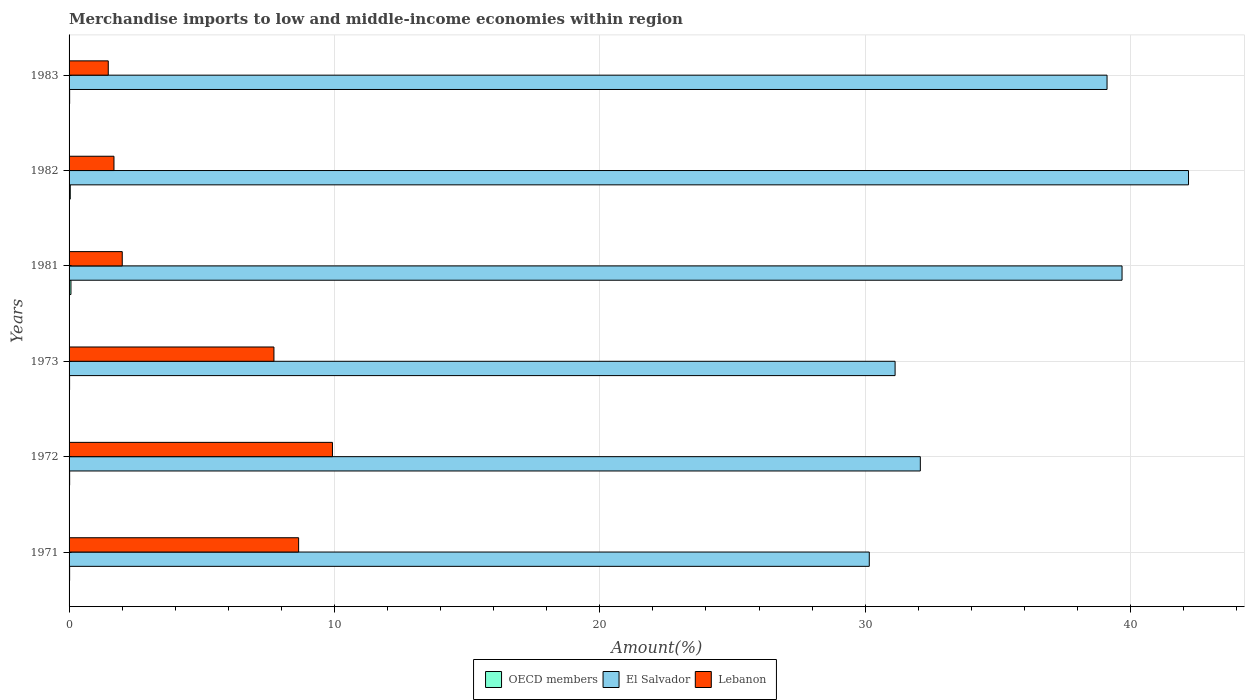Are the number of bars per tick equal to the number of legend labels?
Give a very brief answer. Yes. What is the label of the 1st group of bars from the top?
Your answer should be compact. 1983. What is the percentage of amount earned from merchandise imports in El Salvador in 1972?
Your answer should be compact. 32.08. Across all years, what is the maximum percentage of amount earned from merchandise imports in El Salvador?
Offer a terse response. 42.19. Across all years, what is the minimum percentage of amount earned from merchandise imports in El Salvador?
Offer a very short reply. 30.16. In which year was the percentage of amount earned from merchandise imports in El Salvador minimum?
Offer a terse response. 1971. What is the total percentage of amount earned from merchandise imports in Lebanon in the graph?
Your answer should be very brief. 31.47. What is the difference between the percentage of amount earned from merchandise imports in El Salvador in 1971 and that in 1981?
Provide a short and direct response. -9.53. What is the difference between the percentage of amount earned from merchandise imports in Lebanon in 1981 and the percentage of amount earned from merchandise imports in OECD members in 1972?
Offer a very short reply. 1.98. What is the average percentage of amount earned from merchandise imports in El Salvador per year?
Ensure brevity in your answer.  35.72. In the year 1983, what is the difference between the percentage of amount earned from merchandise imports in Lebanon and percentage of amount earned from merchandise imports in OECD members?
Make the answer very short. 1.46. In how many years, is the percentage of amount earned from merchandise imports in Lebanon greater than 16 %?
Offer a very short reply. 0. What is the ratio of the percentage of amount earned from merchandise imports in OECD members in 1973 to that in 1981?
Provide a short and direct response. 0.28. Is the percentage of amount earned from merchandise imports in Lebanon in 1971 less than that in 1981?
Provide a short and direct response. No. Is the difference between the percentage of amount earned from merchandise imports in Lebanon in 1981 and 1982 greater than the difference between the percentage of amount earned from merchandise imports in OECD members in 1981 and 1982?
Your response must be concise. Yes. What is the difference between the highest and the second highest percentage of amount earned from merchandise imports in Lebanon?
Give a very brief answer. 1.28. What is the difference between the highest and the lowest percentage of amount earned from merchandise imports in El Salvador?
Your answer should be compact. 12.03. In how many years, is the percentage of amount earned from merchandise imports in Lebanon greater than the average percentage of amount earned from merchandise imports in Lebanon taken over all years?
Make the answer very short. 3. What does the 2nd bar from the top in 1982 represents?
Offer a terse response. El Salvador. What does the 3rd bar from the bottom in 1973 represents?
Your response must be concise. Lebanon. Is it the case that in every year, the sum of the percentage of amount earned from merchandise imports in Lebanon and percentage of amount earned from merchandise imports in El Salvador is greater than the percentage of amount earned from merchandise imports in OECD members?
Your answer should be very brief. Yes. How many bars are there?
Keep it short and to the point. 18. What is the difference between two consecutive major ticks on the X-axis?
Offer a very short reply. 10. Are the values on the major ticks of X-axis written in scientific E-notation?
Give a very brief answer. No. Does the graph contain any zero values?
Offer a terse response. No. How many legend labels are there?
Ensure brevity in your answer.  3. What is the title of the graph?
Your answer should be very brief. Merchandise imports to low and middle-income economies within region. What is the label or title of the X-axis?
Provide a short and direct response. Amount(%). What is the label or title of the Y-axis?
Give a very brief answer. Years. What is the Amount(%) of OECD members in 1971?
Keep it short and to the point. 0.02. What is the Amount(%) in El Salvador in 1971?
Provide a succinct answer. 30.16. What is the Amount(%) in Lebanon in 1971?
Give a very brief answer. 8.65. What is the Amount(%) in OECD members in 1972?
Your response must be concise. 0.02. What is the Amount(%) of El Salvador in 1972?
Provide a succinct answer. 32.08. What is the Amount(%) of Lebanon in 1972?
Provide a succinct answer. 9.93. What is the Amount(%) in OECD members in 1973?
Offer a very short reply. 0.02. What is the Amount(%) of El Salvador in 1973?
Keep it short and to the point. 31.13. What is the Amount(%) in Lebanon in 1973?
Give a very brief answer. 7.72. What is the Amount(%) of OECD members in 1981?
Ensure brevity in your answer.  0.07. What is the Amount(%) in El Salvador in 1981?
Offer a very short reply. 39.68. What is the Amount(%) of Lebanon in 1981?
Ensure brevity in your answer.  2. What is the Amount(%) of OECD members in 1982?
Your response must be concise. 0.05. What is the Amount(%) in El Salvador in 1982?
Provide a short and direct response. 42.19. What is the Amount(%) in Lebanon in 1982?
Your answer should be compact. 1.69. What is the Amount(%) of OECD members in 1983?
Provide a succinct answer. 0.02. What is the Amount(%) of El Salvador in 1983?
Your answer should be very brief. 39.12. What is the Amount(%) in Lebanon in 1983?
Give a very brief answer. 1.48. Across all years, what is the maximum Amount(%) in OECD members?
Your answer should be very brief. 0.07. Across all years, what is the maximum Amount(%) of El Salvador?
Keep it short and to the point. 42.19. Across all years, what is the maximum Amount(%) in Lebanon?
Make the answer very short. 9.93. Across all years, what is the minimum Amount(%) of OECD members?
Make the answer very short. 0.02. Across all years, what is the minimum Amount(%) of El Salvador?
Offer a very short reply. 30.16. Across all years, what is the minimum Amount(%) of Lebanon?
Give a very brief answer. 1.48. What is the total Amount(%) in OECD members in the graph?
Provide a succinct answer. 0.2. What is the total Amount(%) in El Salvador in the graph?
Your answer should be very brief. 214.34. What is the total Amount(%) of Lebanon in the graph?
Keep it short and to the point. 31.47. What is the difference between the Amount(%) of OECD members in 1971 and that in 1972?
Offer a very short reply. -0. What is the difference between the Amount(%) in El Salvador in 1971 and that in 1972?
Your response must be concise. -1.92. What is the difference between the Amount(%) of Lebanon in 1971 and that in 1972?
Make the answer very short. -1.28. What is the difference between the Amount(%) in OECD members in 1971 and that in 1973?
Your answer should be compact. 0. What is the difference between the Amount(%) in El Salvador in 1971 and that in 1973?
Provide a short and direct response. -0.97. What is the difference between the Amount(%) in OECD members in 1971 and that in 1981?
Offer a terse response. -0.05. What is the difference between the Amount(%) of El Salvador in 1971 and that in 1981?
Your response must be concise. -9.53. What is the difference between the Amount(%) in Lebanon in 1971 and that in 1981?
Give a very brief answer. 6.65. What is the difference between the Amount(%) of OECD members in 1971 and that in 1982?
Ensure brevity in your answer.  -0.02. What is the difference between the Amount(%) in El Salvador in 1971 and that in 1982?
Ensure brevity in your answer.  -12.03. What is the difference between the Amount(%) of Lebanon in 1971 and that in 1982?
Make the answer very short. 6.96. What is the difference between the Amount(%) of OECD members in 1971 and that in 1983?
Provide a short and direct response. -0. What is the difference between the Amount(%) of El Salvador in 1971 and that in 1983?
Make the answer very short. -8.96. What is the difference between the Amount(%) in Lebanon in 1971 and that in 1983?
Offer a very short reply. 7.17. What is the difference between the Amount(%) of OECD members in 1972 and that in 1973?
Offer a very short reply. 0. What is the difference between the Amount(%) of El Salvador in 1972 and that in 1973?
Offer a terse response. 0.95. What is the difference between the Amount(%) in Lebanon in 1972 and that in 1973?
Give a very brief answer. 2.21. What is the difference between the Amount(%) of OECD members in 1972 and that in 1981?
Your response must be concise. -0.05. What is the difference between the Amount(%) of El Salvador in 1972 and that in 1981?
Provide a succinct answer. -7.6. What is the difference between the Amount(%) in Lebanon in 1972 and that in 1981?
Provide a succinct answer. 7.92. What is the difference between the Amount(%) of OECD members in 1972 and that in 1982?
Provide a short and direct response. -0.02. What is the difference between the Amount(%) of El Salvador in 1972 and that in 1982?
Offer a very short reply. -10.11. What is the difference between the Amount(%) of Lebanon in 1972 and that in 1982?
Ensure brevity in your answer.  8.23. What is the difference between the Amount(%) of El Salvador in 1972 and that in 1983?
Provide a short and direct response. -7.04. What is the difference between the Amount(%) in Lebanon in 1972 and that in 1983?
Your response must be concise. 8.45. What is the difference between the Amount(%) in OECD members in 1973 and that in 1981?
Give a very brief answer. -0.05. What is the difference between the Amount(%) in El Salvador in 1973 and that in 1981?
Give a very brief answer. -8.55. What is the difference between the Amount(%) in Lebanon in 1973 and that in 1981?
Offer a terse response. 5.72. What is the difference between the Amount(%) of OECD members in 1973 and that in 1982?
Give a very brief answer. -0.03. What is the difference between the Amount(%) in El Salvador in 1973 and that in 1982?
Keep it short and to the point. -11.06. What is the difference between the Amount(%) in Lebanon in 1973 and that in 1982?
Keep it short and to the point. 6.03. What is the difference between the Amount(%) in OECD members in 1973 and that in 1983?
Ensure brevity in your answer.  -0. What is the difference between the Amount(%) in El Salvador in 1973 and that in 1983?
Give a very brief answer. -7.99. What is the difference between the Amount(%) in Lebanon in 1973 and that in 1983?
Your answer should be compact. 6.24. What is the difference between the Amount(%) of OECD members in 1981 and that in 1982?
Give a very brief answer. 0.03. What is the difference between the Amount(%) of El Salvador in 1981 and that in 1982?
Provide a short and direct response. -2.51. What is the difference between the Amount(%) in Lebanon in 1981 and that in 1982?
Your response must be concise. 0.31. What is the difference between the Amount(%) in OECD members in 1981 and that in 1983?
Offer a very short reply. 0.05. What is the difference between the Amount(%) in El Salvador in 1981 and that in 1983?
Your answer should be very brief. 0.57. What is the difference between the Amount(%) of Lebanon in 1981 and that in 1983?
Your answer should be very brief. 0.53. What is the difference between the Amount(%) of OECD members in 1982 and that in 1983?
Provide a short and direct response. 0.02. What is the difference between the Amount(%) in El Salvador in 1982 and that in 1983?
Offer a very short reply. 3.07. What is the difference between the Amount(%) in Lebanon in 1982 and that in 1983?
Your answer should be compact. 0.21. What is the difference between the Amount(%) of OECD members in 1971 and the Amount(%) of El Salvador in 1972?
Offer a terse response. -32.06. What is the difference between the Amount(%) in OECD members in 1971 and the Amount(%) in Lebanon in 1972?
Ensure brevity in your answer.  -9.9. What is the difference between the Amount(%) of El Salvador in 1971 and the Amount(%) of Lebanon in 1972?
Give a very brief answer. 20.23. What is the difference between the Amount(%) in OECD members in 1971 and the Amount(%) in El Salvador in 1973?
Offer a terse response. -31.11. What is the difference between the Amount(%) of OECD members in 1971 and the Amount(%) of Lebanon in 1973?
Offer a very short reply. -7.7. What is the difference between the Amount(%) of El Salvador in 1971 and the Amount(%) of Lebanon in 1973?
Provide a short and direct response. 22.43. What is the difference between the Amount(%) in OECD members in 1971 and the Amount(%) in El Salvador in 1981?
Provide a succinct answer. -39.66. What is the difference between the Amount(%) of OECD members in 1971 and the Amount(%) of Lebanon in 1981?
Your answer should be compact. -1.98. What is the difference between the Amount(%) in El Salvador in 1971 and the Amount(%) in Lebanon in 1981?
Your response must be concise. 28.15. What is the difference between the Amount(%) in OECD members in 1971 and the Amount(%) in El Salvador in 1982?
Offer a very short reply. -42.16. What is the difference between the Amount(%) of OECD members in 1971 and the Amount(%) of Lebanon in 1982?
Provide a succinct answer. -1.67. What is the difference between the Amount(%) of El Salvador in 1971 and the Amount(%) of Lebanon in 1982?
Your answer should be compact. 28.46. What is the difference between the Amount(%) of OECD members in 1971 and the Amount(%) of El Salvador in 1983?
Your answer should be very brief. -39.09. What is the difference between the Amount(%) in OECD members in 1971 and the Amount(%) in Lebanon in 1983?
Your answer should be very brief. -1.46. What is the difference between the Amount(%) of El Salvador in 1971 and the Amount(%) of Lebanon in 1983?
Keep it short and to the point. 28.68. What is the difference between the Amount(%) of OECD members in 1972 and the Amount(%) of El Salvador in 1973?
Provide a succinct answer. -31.11. What is the difference between the Amount(%) in OECD members in 1972 and the Amount(%) in Lebanon in 1973?
Provide a short and direct response. -7.7. What is the difference between the Amount(%) in El Salvador in 1972 and the Amount(%) in Lebanon in 1973?
Ensure brevity in your answer.  24.36. What is the difference between the Amount(%) in OECD members in 1972 and the Amount(%) in El Salvador in 1981?
Your response must be concise. -39.66. What is the difference between the Amount(%) of OECD members in 1972 and the Amount(%) of Lebanon in 1981?
Offer a terse response. -1.98. What is the difference between the Amount(%) in El Salvador in 1972 and the Amount(%) in Lebanon in 1981?
Provide a succinct answer. 30.07. What is the difference between the Amount(%) in OECD members in 1972 and the Amount(%) in El Salvador in 1982?
Provide a succinct answer. -42.16. What is the difference between the Amount(%) of OECD members in 1972 and the Amount(%) of Lebanon in 1982?
Your answer should be very brief. -1.67. What is the difference between the Amount(%) of El Salvador in 1972 and the Amount(%) of Lebanon in 1982?
Provide a succinct answer. 30.39. What is the difference between the Amount(%) of OECD members in 1972 and the Amount(%) of El Salvador in 1983?
Provide a short and direct response. -39.09. What is the difference between the Amount(%) in OECD members in 1972 and the Amount(%) in Lebanon in 1983?
Offer a very short reply. -1.46. What is the difference between the Amount(%) of El Salvador in 1972 and the Amount(%) of Lebanon in 1983?
Your answer should be compact. 30.6. What is the difference between the Amount(%) in OECD members in 1973 and the Amount(%) in El Salvador in 1981?
Make the answer very short. -39.66. What is the difference between the Amount(%) of OECD members in 1973 and the Amount(%) of Lebanon in 1981?
Your answer should be compact. -1.98. What is the difference between the Amount(%) of El Salvador in 1973 and the Amount(%) of Lebanon in 1981?
Provide a succinct answer. 29.12. What is the difference between the Amount(%) in OECD members in 1973 and the Amount(%) in El Salvador in 1982?
Offer a terse response. -42.17. What is the difference between the Amount(%) of OECD members in 1973 and the Amount(%) of Lebanon in 1982?
Provide a short and direct response. -1.67. What is the difference between the Amount(%) of El Salvador in 1973 and the Amount(%) of Lebanon in 1982?
Your answer should be compact. 29.44. What is the difference between the Amount(%) of OECD members in 1973 and the Amount(%) of El Salvador in 1983?
Give a very brief answer. -39.1. What is the difference between the Amount(%) of OECD members in 1973 and the Amount(%) of Lebanon in 1983?
Ensure brevity in your answer.  -1.46. What is the difference between the Amount(%) in El Salvador in 1973 and the Amount(%) in Lebanon in 1983?
Keep it short and to the point. 29.65. What is the difference between the Amount(%) in OECD members in 1981 and the Amount(%) in El Salvador in 1982?
Your answer should be compact. -42.12. What is the difference between the Amount(%) in OECD members in 1981 and the Amount(%) in Lebanon in 1982?
Keep it short and to the point. -1.62. What is the difference between the Amount(%) in El Salvador in 1981 and the Amount(%) in Lebanon in 1982?
Your answer should be compact. 37.99. What is the difference between the Amount(%) in OECD members in 1981 and the Amount(%) in El Salvador in 1983?
Your answer should be very brief. -39.04. What is the difference between the Amount(%) in OECD members in 1981 and the Amount(%) in Lebanon in 1983?
Your answer should be compact. -1.41. What is the difference between the Amount(%) of El Salvador in 1981 and the Amount(%) of Lebanon in 1983?
Provide a succinct answer. 38.2. What is the difference between the Amount(%) in OECD members in 1982 and the Amount(%) in El Salvador in 1983?
Provide a short and direct response. -39.07. What is the difference between the Amount(%) of OECD members in 1982 and the Amount(%) of Lebanon in 1983?
Provide a short and direct response. -1.43. What is the difference between the Amount(%) in El Salvador in 1982 and the Amount(%) in Lebanon in 1983?
Offer a very short reply. 40.71. What is the average Amount(%) of El Salvador per year?
Your answer should be very brief. 35.72. What is the average Amount(%) in Lebanon per year?
Offer a very short reply. 5.24. In the year 1971, what is the difference between the Amount(%) of OECD members and Amount(%) of El Salvador?
Provide a succinct answer. -30.13. In the year 1971, what is the difference between the Amount(%) of OECD members and Amount(%) of Lebanon?
Provide a succinct answer. -8.63. In the year 1971, what is the difference between the Amount(%) in El Salvador and Amount(%) in Lebanon?
Keep it short and to the point. 21.5. In the year 1972, what is the difference between the Amount(%) of OECD members and Amount(%) of El Salvador?
Your response must be concise. -32.06. In the year 1972, what is the difference between the Amount(%) of OECD members and Amount(%) of Lebanon?
Offer a very short reply. -9.9. In the year 1972, what is the difference between the Amount(%) in El Salvador and Amount(%) in Lebanon?
Make the answer very short. 22.15. In the year 1973, what is the difference between the Amount(%) in OECD members and Amount(%) in El Salvador?
Keep it short and to the point. -31.11. In the year 1973, what is the difference between the Amount(%) of OECD members and Amount(%) of Lebanon?
Your answer should be compact. -7.7. In the year 1973, what is the difference between the Amount(%) in El Salvador and Amount(%) in Lebanon?
Your answer should be compact. 23.41. In the year 1981, what is the difference between the Amount(%) in OECD members and Amount(%) in El Salvador?
Provide a succinct answer. -39.61. In the year 1981, what is the difference between the Amount(%) of OECD members and Amount(%) of Lebanon?
Provide a succinct answer. -1.93. In the year 1981, what is the difference between the Amount(%) of El Salvador and Amount(%) of Lebanon?
Provide a short and direct response. 37.68. In the year 1982, what is the difference between the Amount(%) of OECD members and Amount(%) of El Salvador?
Provide a succinct answer. -42.14. In the year 1982, what is the difference between the Amount(%) in OECD members and Amount(%) in Lebanon?
Ensure brevity in your answer.  -1.65. In the year 1982, what is the difference between the Amount(%) of El Salvador and Amount(%) of Lebanon?
Provide a succinct answer. 40.49. In the year 1983, what is the difference between the Amount(%) of OECD members and Amount(%) of El Salvador?
Your answer should be compact. -39.09. In the year 1983, what is the difference between the Amount(%) of OECD members and Amount(%) of Lebanon?
Offer a very short reply. -1.46. In the year 1983, what is the difference between the Amount(%) in El Salvador and Amount(%) in Lebanon?
Ensure brevity in your answer.  37.64. What is the ratio of the Amount(%) of OECD members in 1971 to that in 1972?
Your answer should be very brief. 0.96. What is the ratio of the Amount(%) in El Salvador in 1971 to that in 1972?
Keep it short and to the point. 0.94. What is the ratio of the Amount(%) of Lebanon in 1971 to that in 1972?
Keep it short and to the point. 0.87. What is the ratio of the Amount(%) of OECD members in 1971 to that in 1973?
Provide a succinct answer. 1.05. What is the ratio of the Amount(%) in El Salvador in 1971 to that in 1973?
Provide a short and direct response. 0.97. What is the ratio of the Amount(%) in Lebanon in 1971 to that in 1973?
Give a very brief answer. 1.12. What is the ratio of the Amount(%) in OECD members in 1971 to that in 1981?
Provide a succinct answer. 0.3. What is the ratio of the Amount(%) in El Salvador in 1971 to that in 1981?
Your response must be concise. 0.76. What is the ratio of the Amount(%) in Lebanon in 1971 to that in 1981?
Make the answer very short. 4.32. What is the ratio of the Amount(%) of OECD members in 1971 to that in 1982?
Offer a terse response. 0.46. What is the ratio of the Amount(%) in El Salvador in 1971 to that in 1982?
Your answer should be very brief. 0.71. What is the ratio of the Amount(%) in Lebanon in 1971 to that in 1982?
Offer a very short reply. 5.11. What is the ratio of the Amount(%) in OECD members in 1971 to that in 1983?
Offer a very short reply. 0.98. What is the ratio of the Amount(%) in El Salvador in 1971 to that in 1983?
Ensure brevity in your answer.  0.77. What is the ratio of the Amount(%) of Lebanon in 1971 to that in 1983?
Offer a terse response. 5.86. What is the ratio of the Amount(%) in OECD members in 1972 to that in 1973?
Ensure brevity in your answer.  1.09. What is the ratio of the Amount(%) in El Salvador in 1972 to that in 1973?
Give a very brief answer. 1.03. What is the ratio of the Amount(%) of Lebanon in 1972 to that in 1973?
Offer a terse response. 1.29. What is the ratio of the Amount(%) in OECD members in 1972 to that in 1981?
Give a very brief answer. 0.31. What is the ratio of the Amount(%) of El Salvador in 1972 to that in 1981?
Offer a terse response. 0.81. What is the ratio of the Amount(%) of Lebanon in 1972 to that in 1981?
Offer a terse response. 4.95. What is the ratio of the Amount(%) in OECD members in 1972 to that in 1982?
Offer a terse response. 0.48. What is the ratio of the Amount(%) in El Salvador in 1972 to that in 1982?
Make the answer very short. 0.76. What is the ratio of the Amount(%) of Lebanon in 1972 to that in 1982?
Provide a succinct answer. 5.87. What is the ratio of the Amount(%) in OECD members in 1972 to that in 1983?
Your response must be concise. 1.02. What is the ratio of the Amount(%) in El Salvador in 1972 to that in 1983?
Provide a succinct answer. 0.82. What is the ratio of the Amount(%) in Lebanon in 1972 to that in 1983?
Offer a very short reply. 6.72. What is the ratio of the Amount(%) in OECD members in 1973 to that in 1981?
Make the answer very short. 0.28. What is the ratio of the Amount(%) of El Salvador in 1973 to that in 1981?
Keep it short and to the point. 0.78. What is the ratio of the Amount(%) in Lebanon in 1973 to that in 1981?
Give a very brief answer. 3.85. What is the ratio of the Amount(%) in OECD members in 1973 to that in 1982?
Offer a very short reply. 0.44. What is the ratio of the Amount(%) of El Salvador in 1973 to that in 1982?
Your response must be concise. 0.74. What is the ratio of the Amount(%) in Lebanon in 1973 to that in 1982?
Provide a short and direct response. 4.56. What is the ratio of the Amount(%) in OECD members in 1973 to that in 1983?
Your answer should be very brief. 0.93. What is the ratio of the Amount(%) in El Salvador in 1973 to that in 1983?
Give a very brief answer. 0.8. What is the ratio of the Amount(%) of Lebanon in 1973 to that in 1983?
Ensure brevity in your answer.  5.23. What is the ratio of the Amount(%) in OECD members in 1981 to that in 1982?
Give a very brief answer. 1.56. What is the ratio of the Amount(%) of El Salvador in 1981 to that in 1982?
Your response must be concise. 0.94. What is the ratio of the Amount(%) in Lebanon in 1981 to that in 1982?
Keep it short and to the point. 1.18. What is the ratio of the Amount(%) of OECD members in 1981 to that in 1983?
Your answer should be very brief. 3.32. What is the ratio of the Amount(%) of El Salvador in 1981 to that in 1983?
Offer a terse response. 1.01. What is the ratio of the Amount(%) of Lebanon in 1981 to that in 1983?
Your answer should be compact. 1.36. What is the ratio of the Amount(%) in OECD members in 1982 to that in 1983?
Keep it short and to the point. 2.12. What is the ratio of the Amount(%) of El Salvador in 1982 to that in 1983?
Make the answer very short. 1.08. What is the ratio of the Amount(%) of Lebanon in 1982 to that in 1983?
Your response must be concise. 1.15. What is the difference between the highest and the second highest Amount(%) of OECD members?
Give a very brief answer. 0.03. What is the difference between the highest and the second highest Amount(%) in El Salvador?
Offer a terse response. 2.51. What is the difference between the highest and the second highest Amount(%) in Lebanon?
Your answer should be very brief. 1.28. What is the difference between the highest and the lowest Amount(%) of OECD members?
Your answer should be compact. 0.05. What is the difference between the highest and the lowest Amount(%) of El Salvador?
Offer a terse response. 12.03. What is the difference between the highest and the lowest Amount(%) in Lebanon?
Provide a succinct answer. 8.45. 